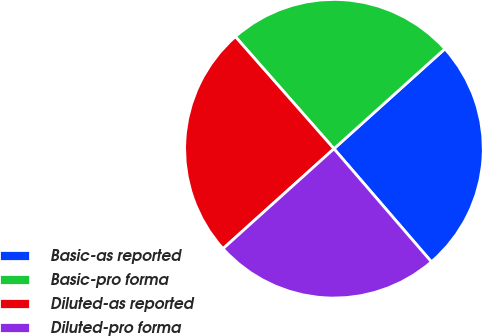Convert chart. <chart><loc_0><loc_0><loc_500><loc_500><pie_chart><fcel>Basic-as reported<fcel>Basic-pro forma<fcel>Diluted-as reported<fcel>Diluted-pro forma<nl><fcel>25.35%<fcel>24.81%<fcel>25.19%<fcel>24.65%<nl></chart> 